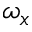<formula> <loc_0><loc_0><loc_500><loc_500>\omega _ { x }</formula> 